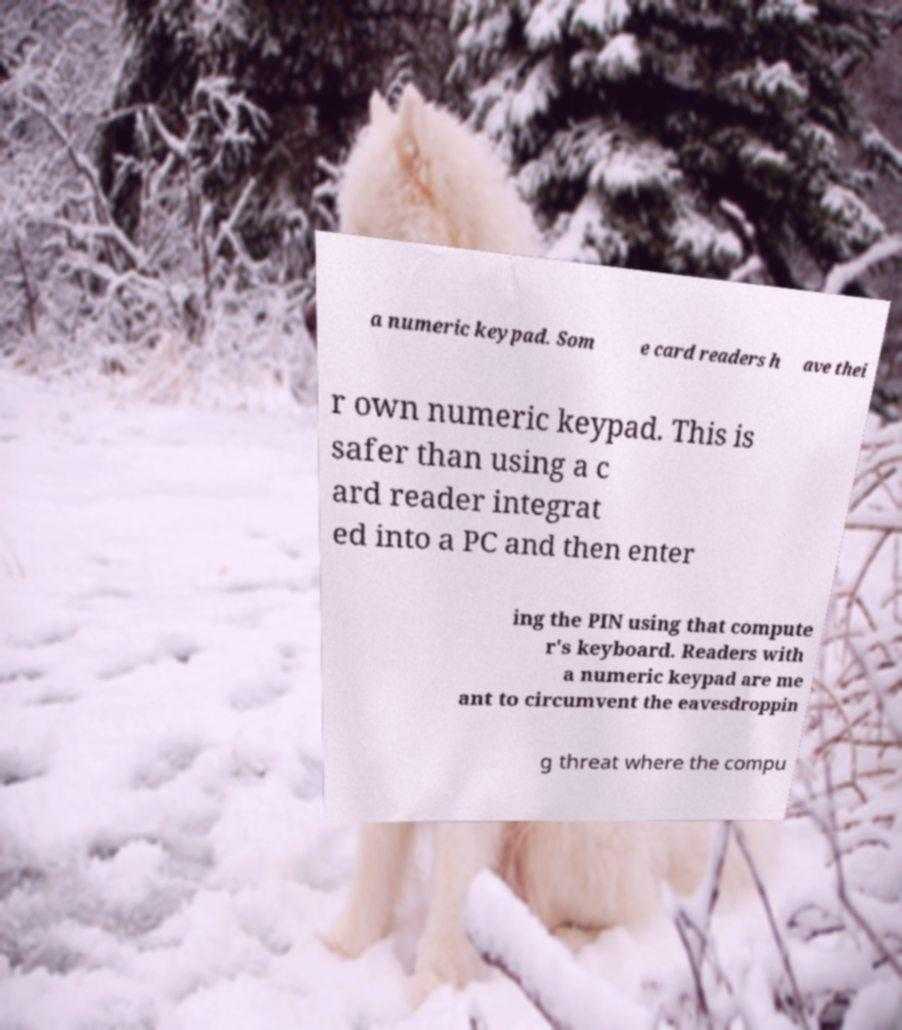Could you assist in decoding the text presented in this image and type it out clearly? a numeric keypad. Som e card readers h ave thei r own numeric keypad. This is safer than using a c ard reader integrat ed into a PC and then enter ing the PIN using that compute r's keyboard. Readers with a numeric keypad are me ant to circumvent the eavesdroppin g threat where the compu 